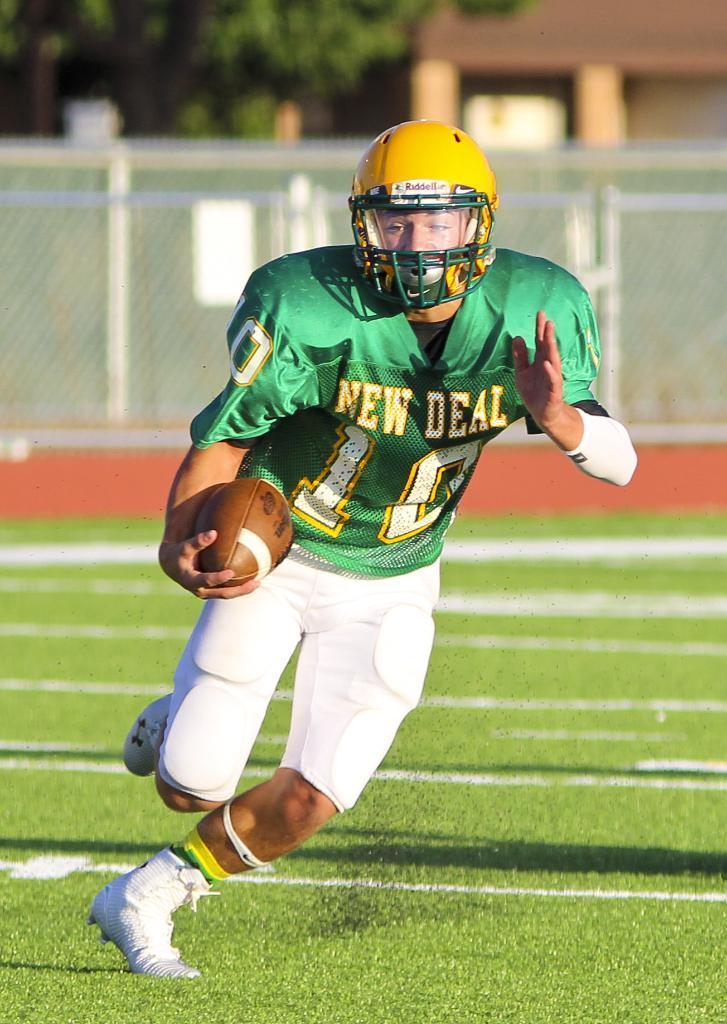How would you summarize this image in a sentence or two? In this image there is a rugby player who is running on the ground by holding the rugby ball. In the background there is a fence. He is wearing the green color jersey and yellow color helmet. In the background there is a house on the right side top and a tree on the left side top. 